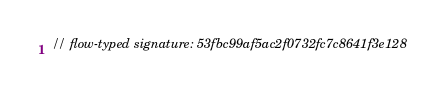<code> <loc_0><loc_0><loc_500><loc_500><_JavaScript_>// flow-typed signature: 53fbc99af5ac2f0732fc7c8641f3e128</code> 